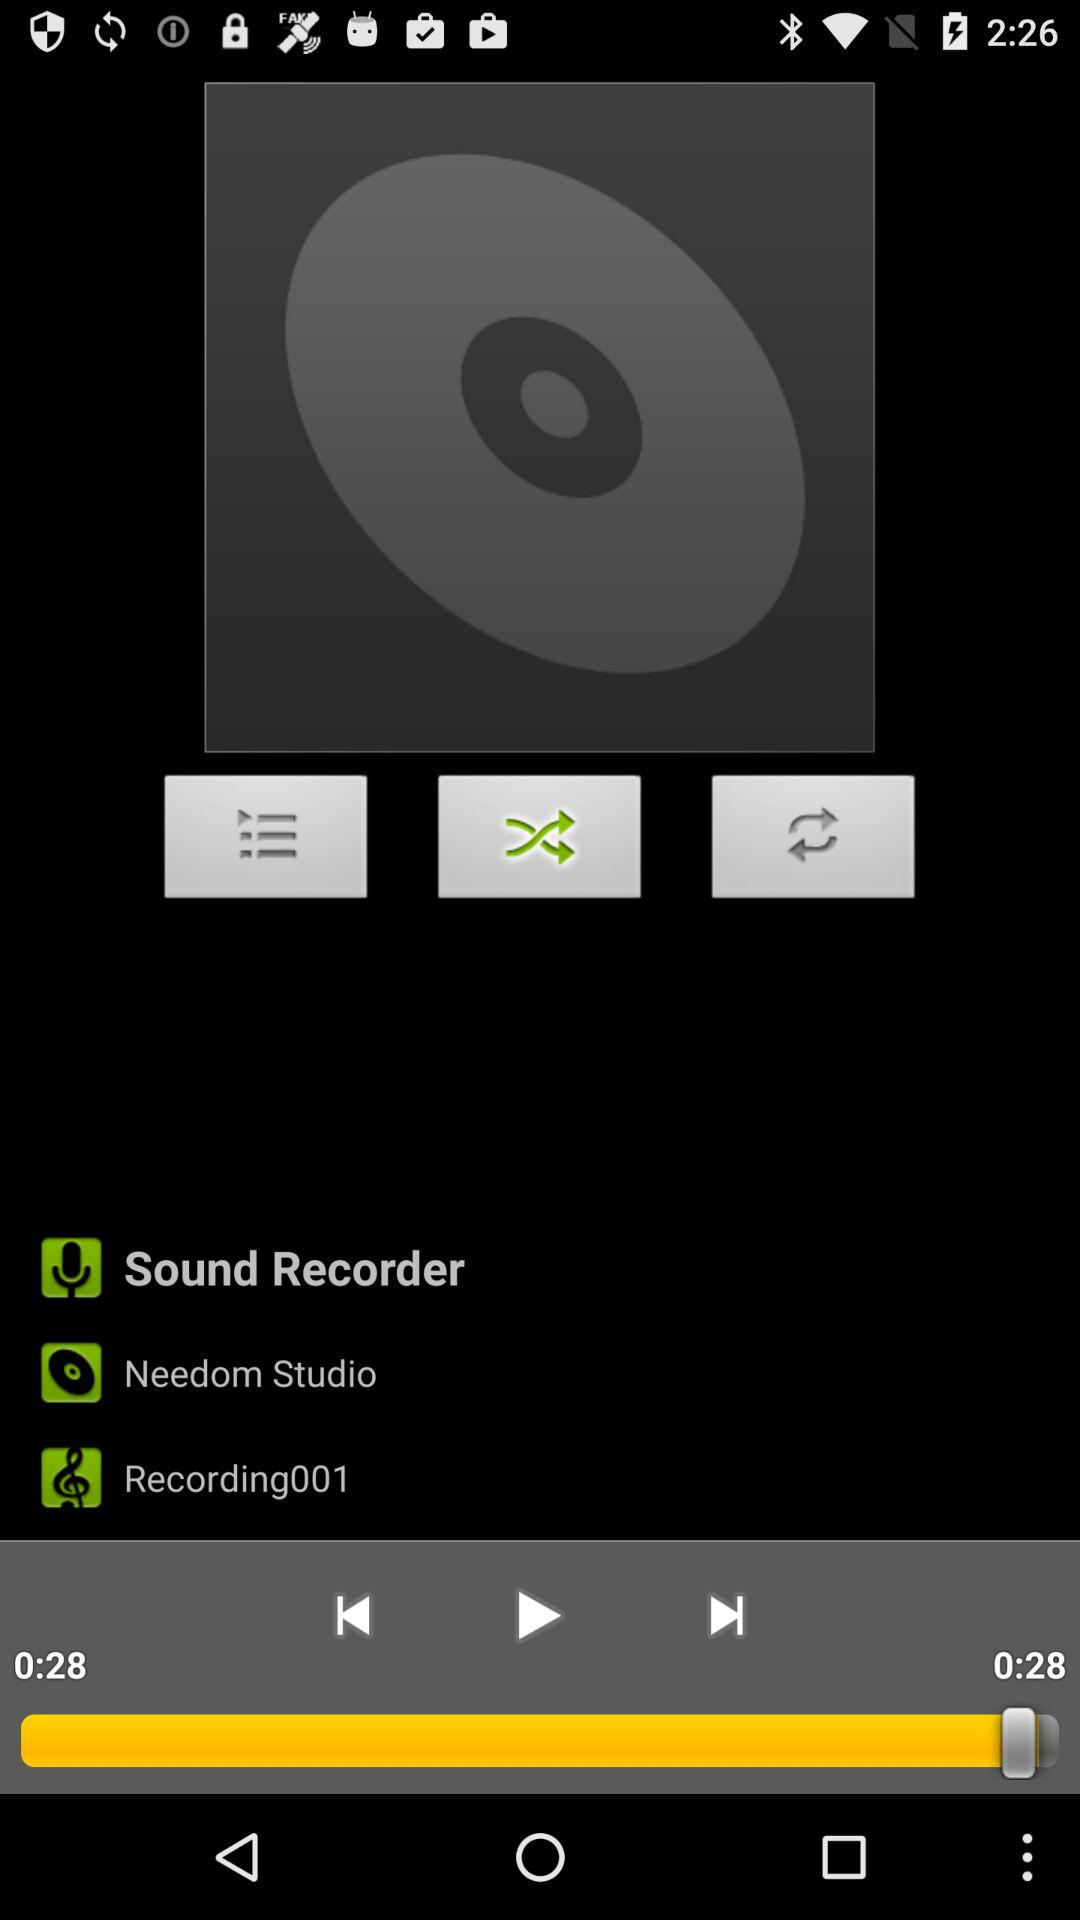What is the selected option? The selected option is "Shuffle". 